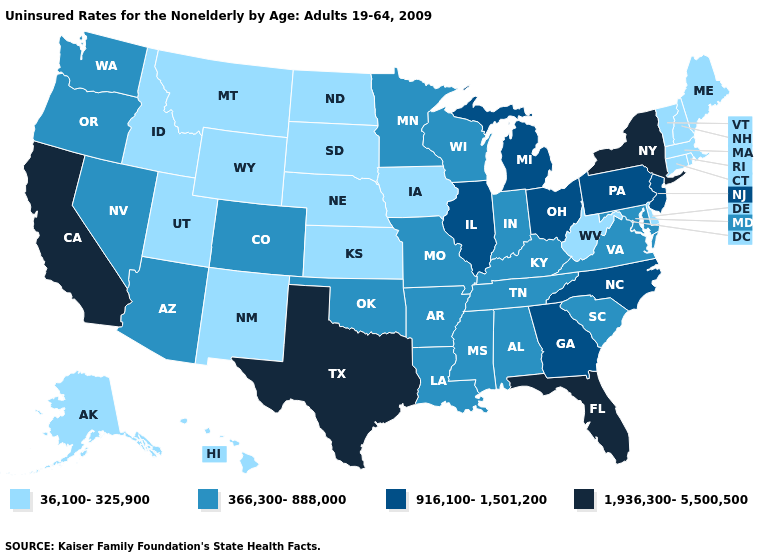Does Hawaii have the highest value in the West?
Keep it brief. No. Name the states that have a value in the range 916,100-1,501,200?
Answer briefly. Georgia, Illinois, Michigan, New Jersey, North Carolina, Ohio, Pennsylvania. What is the highest value in the USA?
Quick response, please. 1,936,300-5,500,500. What is the value of New Hampshire?
Give a very brief answer. 36,100-325,900. Name the states that have a value in the range 1,936,300-5,500,500?
Write a very short answer. California, Florida, New York, Texas. What is the highest value in states that border Ohio?
Write a very short answer. 916,100-1,501,200. What is the value of Washington?
Give a very brief answer. 366,300-888,000. Does Texas have the highest value in the South?
Concise answer only. Yes. Name the states that have a value in the range 36,100-325,900?
Keep it brief. Alaska, Connecticut, Delaware, Hawaii, Idaho, Iowa, Kansas, Maine, Massachusetts, Montana, Nebraska, New Hampshire, New Mexico, North Dakota, Rhode Island, South Dakota, Utah, Vermont, West Virginia, Wyoming. Does the map have missing data?
Answer briefly. No. What is the value of Utah?
Keep it brief. 36,100-325,900. Name the states that have a value in the range 36,100-325,900?
Quick response, please. Alaska, Connecticut, Delaware, Hawaii, Idaho, Iowa, Kansas, Maine, Massachusetts, Montana, Nebraska, New Hampshire, New Mexico, North Dakota, Rhode Island, South Dakota, Utah, Vermont, West Virginia, Wyoming. What is the value of Arizona?
Be succinct. 366,300-888,000. Is the legend a continuous bar?
Answer briefly. No. Name the states that have a value in the range 1,936,300-5,500,500?
Give a very brief answer. California, Florida, New York, Texas. 